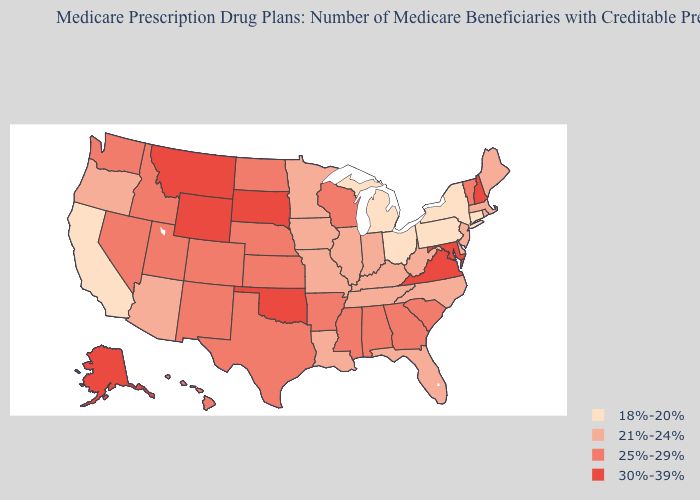What is the lowest value in states that border Vermont?
Concise answer only. 18%-20%. What is the lowest value in states that border Delaware?
Quick response, please. 18%-20%. Is the legend a continuous bar?
Be succinct. No. Among the states that border Wisconsin , does Michigan have the highest value?
Write a very short answer. No. What is the value of Minnesota?
Write a very short answer. 21%-24%. Which states hav the highest value in the South?
Give a very brief answer. Maryland, Oklahoma, Virginia. What is the highest value in the USA?
Short answer required. 30%-39%. What is the value of New Jersey?
Quick response, please. 21%-24%. What is the value of Georgia?
Write a very short answer. 25%-29%. Which states have the highest value in the USA?
Answer briefly. Alaska, Maryland, Montana, New Hampshire, Oklahoma, South Dakota, Virginia, Wyoming. Name the states that have a value in the range 30%-39%?
Answer briefly. Alaska, Maryland, Montana, New Hampshire, Oklahoma, South Dakota, Virginia, Wyoming. Does Washington have the lowest value in the West?
Keep it brief. No. Name the states that have a value in the range 18%-20%?
Write a very short answer. California, Connecticut, Michigan, New York, Ohio, Pennsylvania. Name the states that have a value in the range 21%-24%?
Be succinct. Arizona, Delaware, Florida, Illinois, Indiana, Iowa, Kentucky, Louisiana, Maine, Massachusetts, Minnesota, Missouri, New Jersey, North Carolina, Oregon, Rhode Island, Tennessee, West Virginia. What is the value of Vermont?
Write a very short answer. 25%-29%. 